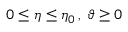<formula> <loc_0><loc_0><loc_500><loc_500>0 \leq \eta \leq \eta _ { 0 } \, , \, \vartheta \geq 0</formula> 